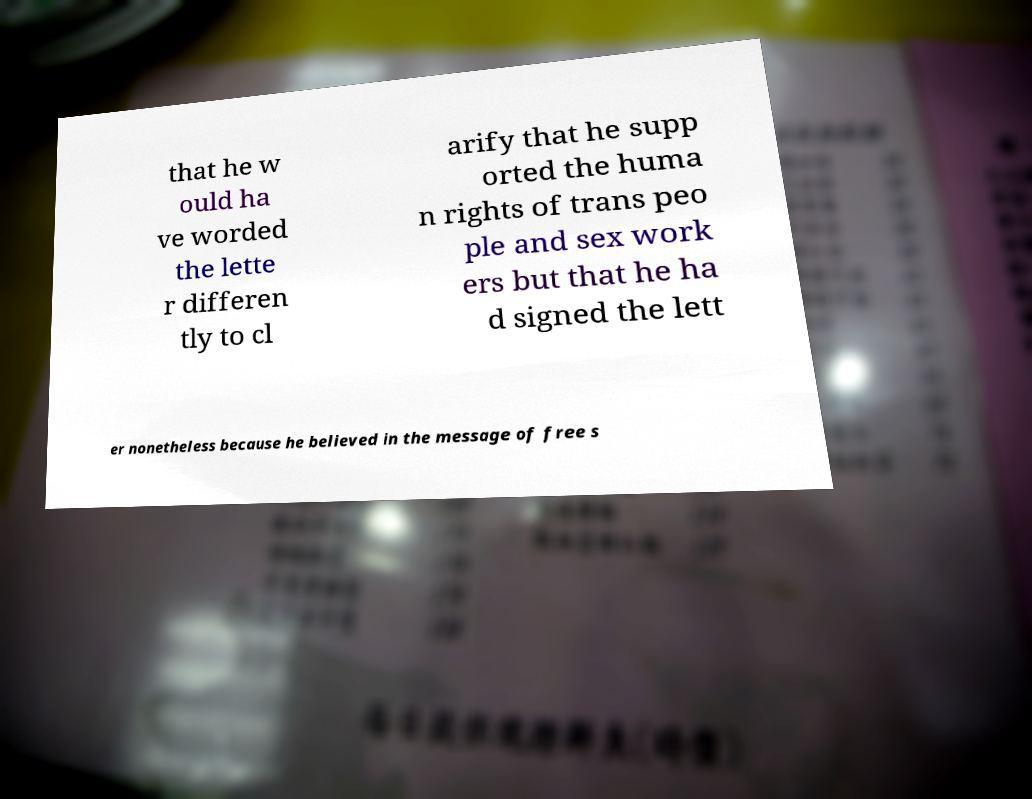For documentation purposes, I need the text within this image transcribed. Could you provide that? that he w ould ha ve worded the lette r differen tly to cl arify that he supp orted the huma n rights of trans peo ple and sex work ers but that he ha d signed the lett er nonetheless because he believed in the message of free s 